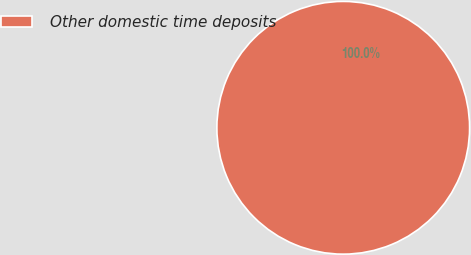Convert chart to OTSL. <chart><loc_0><loc_0><loc_500><loc_500><pie_chart><fcel>Other domestic time deposits<nl><fcel>100.0%<nl></chart> 